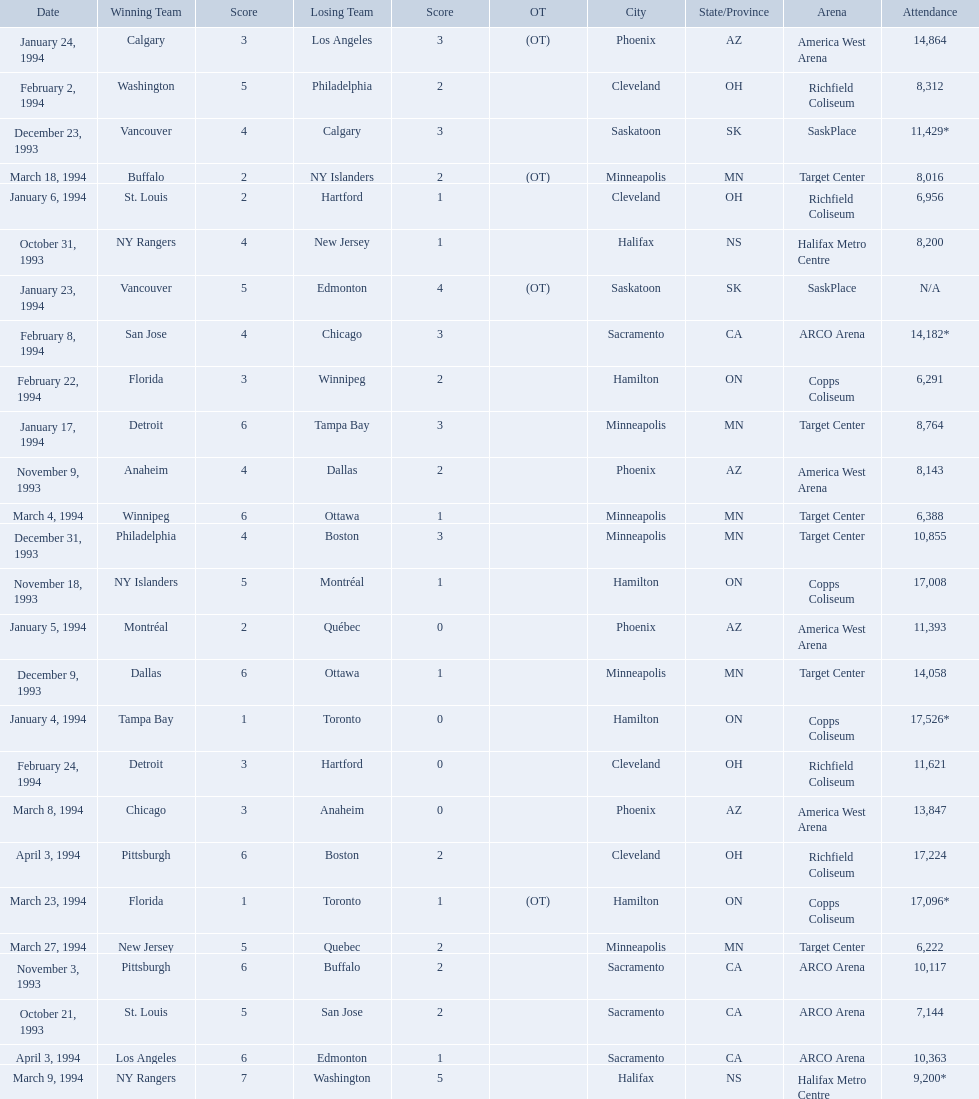When were the games played? October 21, 1993, October 31, 1993, November 3, 1993, November 9, 1993, November 18, 1993, December 9, 1993, December 23, 1993, December 31, 1993, January 4, 1994, January 5, 1994, January 6, 1994, January 17, 1994, January 23, 1994, January 24, 1994, February 2, 1994, February 8, 1994, February 22, 1994, February 24, 1994, March 4, 1994, March 8, 1994, March 9, 1994, March 18, 1994, March 23, 1994, March 27, 1994, April 3, 1994, April 3, 1994. What was the attendance for those games? 7,144, 8,200, 10,117, 8,143, 17,008, 14,058, 11,429*, 10,855, 17,526*, 11,393, 6,956, 8,764, N/A, 14,864, 8,312, 14,182*, 6,291, 11,621, 6,388, 13,847, 9,200*, 8,016, 17,096*, 6,222, 17,224, 10,363. Which date had the highest attendance? January 4, 1994. What are the attendances of the 1993-94 nhl season? 7,144, 8,200, 10,117, 8,143, 17,008, 14,058, 11,429*, 10,855, 17,526*, 11,393, 6,956, 8,764, N/A, 14,864, 8,312, 14,182*, 6,291, 11,621, 6,388, 13,847, 9,200*, 8,016, 17,096*, 6,222, 17,224, 10,363. Which of these is the highest attendance? 17,526*. Which date did this attendance occur? January 4, 1994. 